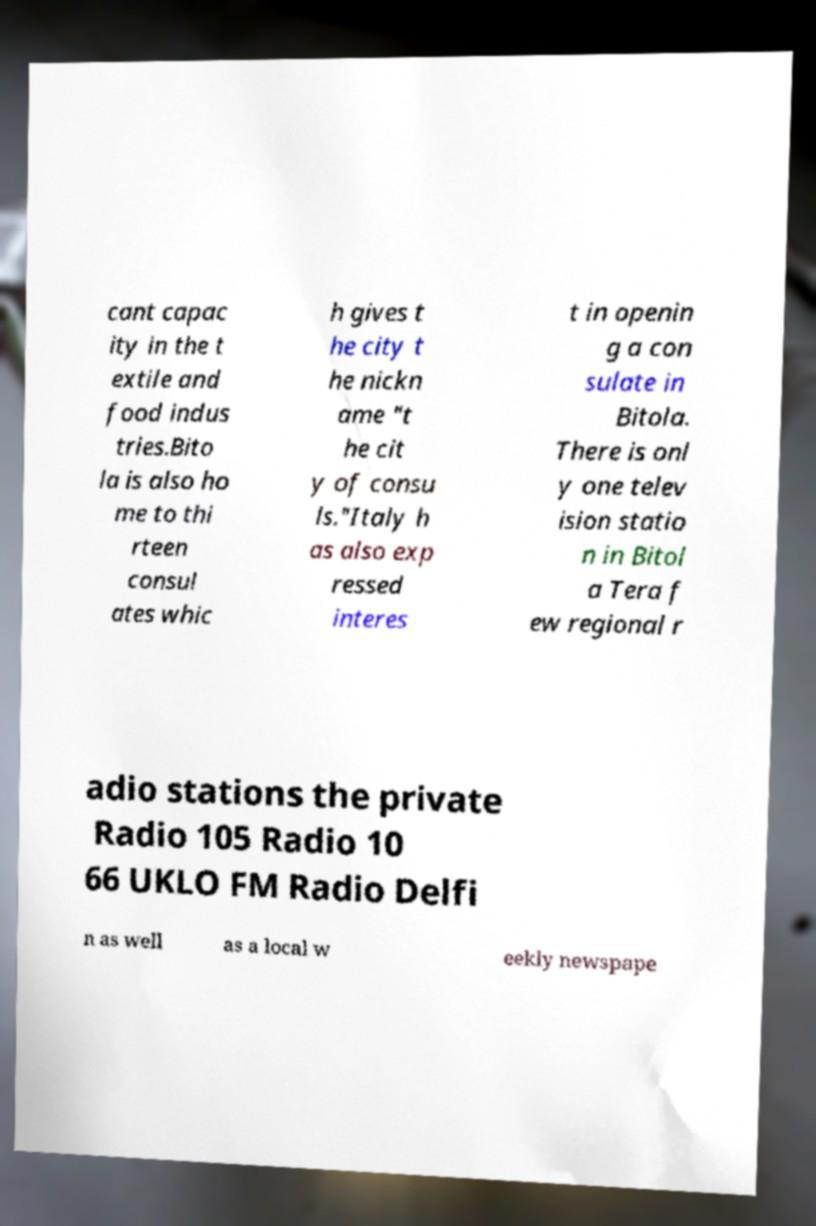Please identify and transcribe the text found in this image. cant capac ity in the t extile and food indus tries.Bito la is also ho me to thi rteen consul ates whic h gives t he city t he nickn ame "t he cit y of consu ls."Italy h as also exp ressed interes t in openin g a con sulate in Bitola. There is onl y one telev ision statio n in Bitol a Tera f ew regional r adio stations the private Radio 105 Radio 10 66 UKLO FM Radio Delfi n as well as a local w eekly newspape 